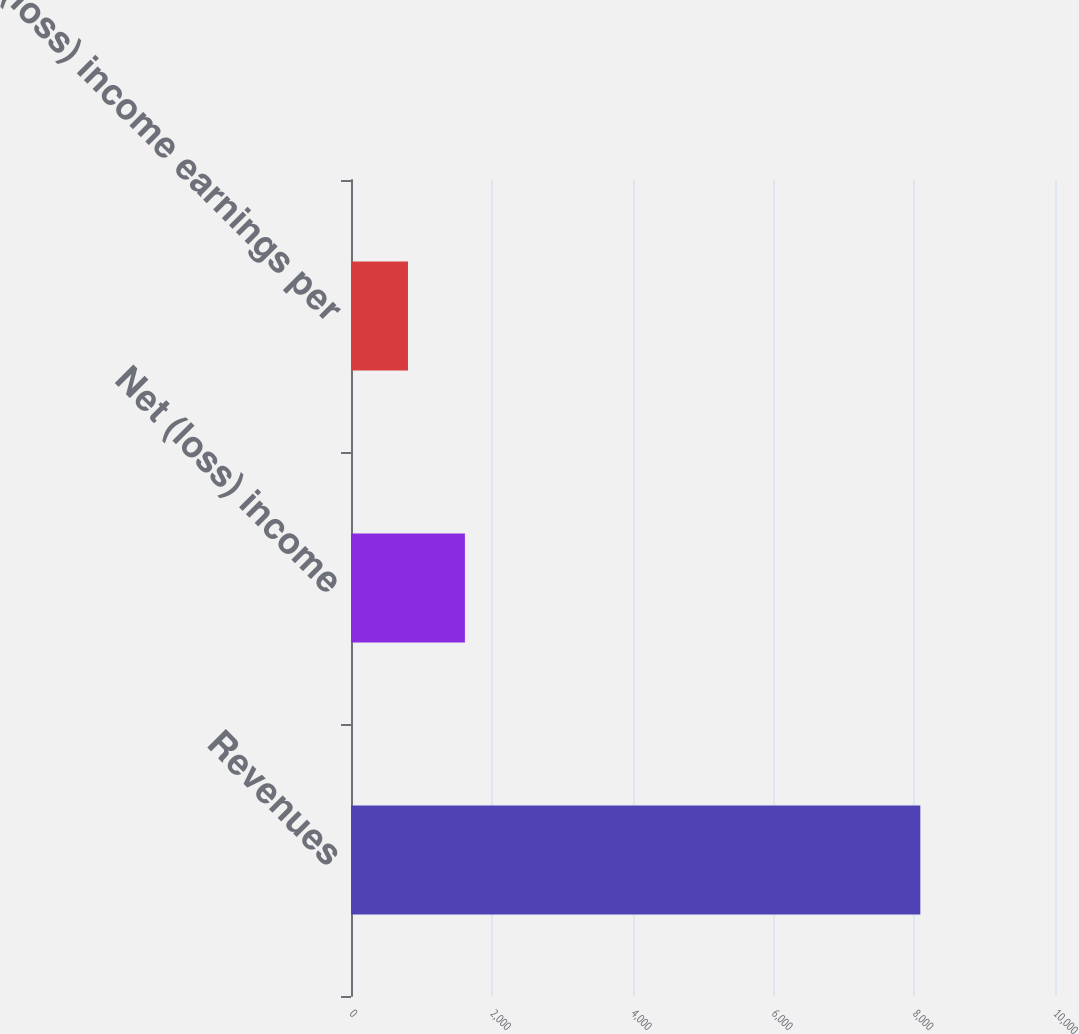<chart> <loc_0><loc_0><loc_500><loc_500><bar_chart><fcel>Revenues<fcel>Net (loss) income<fcel>Net (loss) income earnings per<nl><fcel>8087<fcel>1617.9<fcel>809.26<nl></chart> 